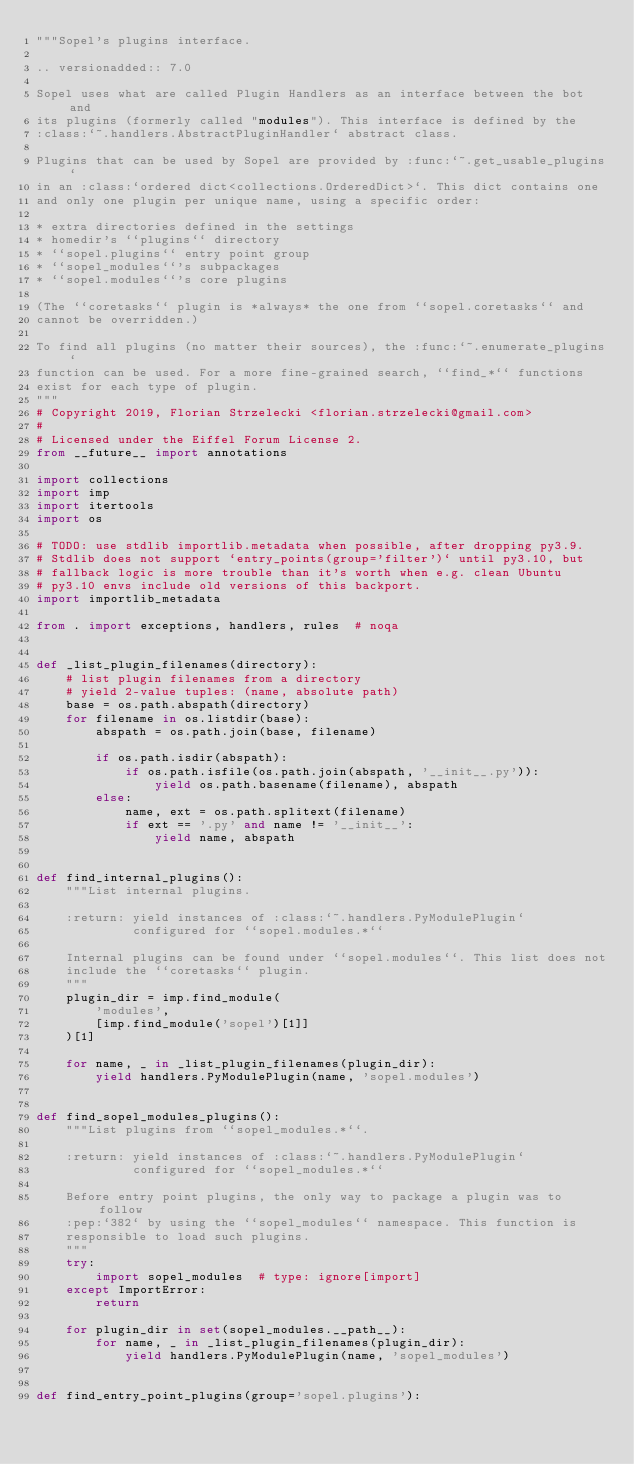<code> <loc_0><loc_0><loc_500><loc_500><_Python_>"""Sopel's plugins interface.

.. versionadded:: 7.0

Sopel uses what are called Plugin Handlers as an interface between the bot and
its plugins (formerly called "modules"). This interface is defined by the
:class:`~.handlers.AbstractPluginHandler` abstract class.

Plugins that can be used by Sopel are provided by :func:`~.get_usable_plugins`
in an :class:`ordered dict<collections.OrderedDict>`. This dict contains one
and only one plugin per unique name, using a specific order:

* extra directories defined in the settings
* homedir's ``plugins`` directory
* ``sopel.plugins`` entry point group
* ``sopel_modules``'s subpackages
* ``sopel.modules``'s core plugins

(The ``coretasks`` plugin is *always* the one from ``sopel.coretasks`` and
cannot be overridden.)

To find all plugins (no matter their sources), the :func:`~.enumerate_plugins`
function can be used. For a more fine-grained search, ``find_*`` functions
exist for each type of plugin.
"""
# Copyright 2019, Florian Strzelecki <florian.strzelecki@gmail.com>
#
# Licensed under the Eiffel Forum License 2.
from __future__ import annotations

import collections
import imp
import itertools
import os

# TODO: use stdlib importlib.metadata when possible, after dropping py3.9.
# Stdlib does not support `entry_points(group='filter')` until py3.10, but
# fallback logic is more trouble than it's worth when e.g. clean Ubuntu
# py3.10 envs include old versions of this backport.
import importlib_metadata

from . import exceptions, handlers, rules  # noqa


def _list_plugin_filenames(directory):
    # list plugin filenames from a directory
    # yield 2-value tuples: (name, absolute path)
    base = os.path.abspath(directory)
    for filename in os.listdir(base):
        abspath = os.path.join(base, filename)

        if os.path.isdir(abspath):
            if os.path.isfile(os.path.join(abspath, '__init__.py')):
                yield os.path.basename(filename), abspath
        else:
            name, ext = os.path.splitext(filename)
            if ext == '.py' and name != '__init__':
                yield name, abspath


def find_internal_plugins():
    """List internal plugins.

    :return: yield instances of :class:`~.handlers.PyModulePlugin`
             configured for ``sopel.modules.*``

    Internal plugins can be found under ``sopel.modules``. This list does not
    include the ``coretasks`` plugin.
    """
    plugin_dir = imp.find_module(
        'modules',
        [imp.find_module('sopel')[1]]
    )[1]

    for name, _ in _list_plugin_filenames(plugin_dir):
        yield handlers.PyModulePlugin(name, 'sopel.modules')


def find_sopel_modules_plugins():
    """List plugins from ``sopel_modules.*``.

    :return: yield instances of :class:`~.handlers.PyModulePlugin`
             configured for ``sopel_modules.*``

    Before entry point plugins, the only way to package a plugin was to follow
    :pep:`382` by using the ``sopel_modules`` namespace. This function is
    responsible to load such plugins.
    """
    try:
        import sopel_modules  # type: ignore[import]
    except ImportError:
        return

    for plugin_dir in set(sopel_modules.__path__):
        for name, _ in _list_plugin_filenames(plugin_dir):
            yield handlers.PyModulePlugin(name, 'sopel_modules')


def find_entry_point_plugins(group='sopel.plugins'):</code> 